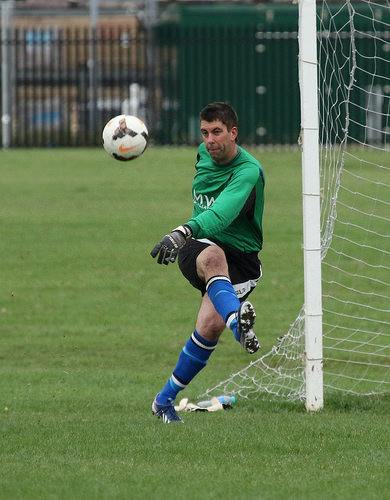<image>
Is there a man on the lawn? Yes. Looking at the image, I can see the man is positioned on top of the lawn, with the lawn providing support. Where is the pillar in relation to the man? Is it to the left of the man? No. The pillar is not to the left of the man. From this viewpoint, they have a different horizontal relationship. Is there a player to the right of the ball? Yes. From this viewpoint, the player is positioned to the right side relative to the ball. Is there a ball in front of the soccer player? Yes. The ball is positioned in front of the soccer player, appearing closer to the camera viewpoint. 